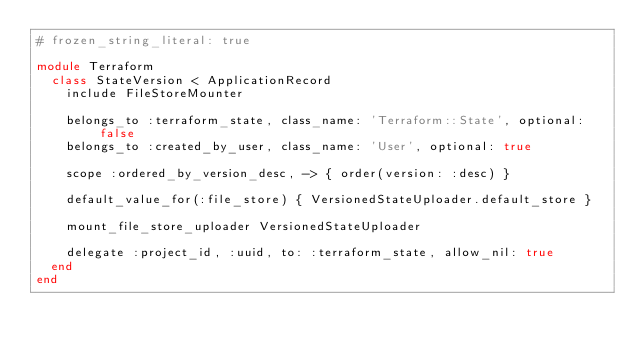<code> <loc_0><loc_0><loc_500><loc_500><_Ruby_># frozen_string_literal: true

module Terraform
  class StateVersion < ApplicationRecord
    include FileStoreMounter

    belongs_to :terraform_state, class_name: 'Terraform::State', optional: false
    belongs_to :created_by_user, class_name: 'User', optional: true

    scope :ordered_by_version_desc, -> { order(version: :desc) }

    default_value_for(:file_store) { VersionedStateUploader.default_store }

    mount_file_store_uploader VersionedStateUploader

    delegate :project_id, :uuid, to: :terraform_state, allow_nil: true
  end
end
</code> 